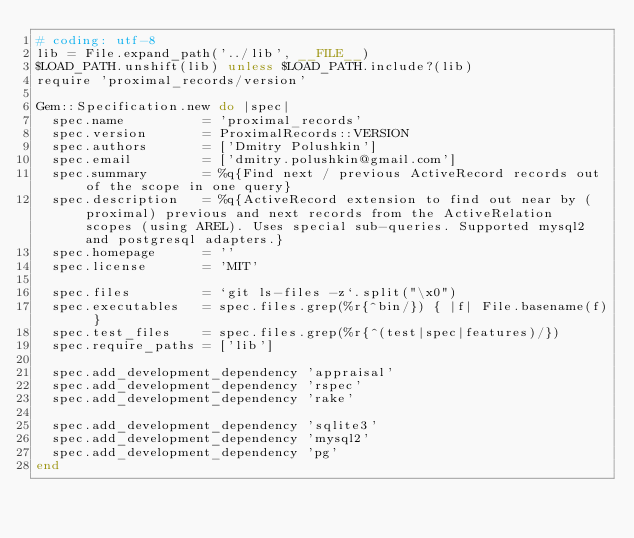<code> <loc_0><loc_0><loc_500><loc_500><_Ruby_># coding: utf-8
lib = File.expand_path('../lib', __FILE__)
$LOAD_PATH.unshift(lib) unless $LOAD_PATH.include?(lib)
require 'proximal_records/version'

Gem::Specification.new do |spec|
  spec.name          = 'proximal_records'
  spec.version       = ProximalRecords::VERSION
  spec.authors       = ['Dmitry Polushkin']
  spec.email         = ['dmitry.polushkin@gmail.com']
  spec.summary       = %q{Find next / previous ActiveRecord records out of the scope in one query}
  spec.description   = %q{ActiveRecord extension to find out near by (proximal) previous and next records from the ActiveRelation scopes (using AREL). Uses special sub-queries. Supported mysql2 and postgresql adapters.}
  spec.homepage      = ''
  spec.license       = 'MIT'

  spec.files         = `git ls-files -z`.split("\x0")
  spec.executables   = spec.files.grep(%r{^bin/}) { |f| File.basename(f) }
  spec.test_files    = spec.files.grep(%r{^(test|spec|features)/})
  spec.require_paths = ['lib']

  spec.add_development_dependency 'appraisal'
  spec.add_development_dependency 'rspec'
  spec.add_development_dependency 'rake'

  spec.add_development_dependency 'sqlite3'
  spec.add_development_dependency 'mysql2'
  spec.add_development_dependency 'pg'
end
</code> 